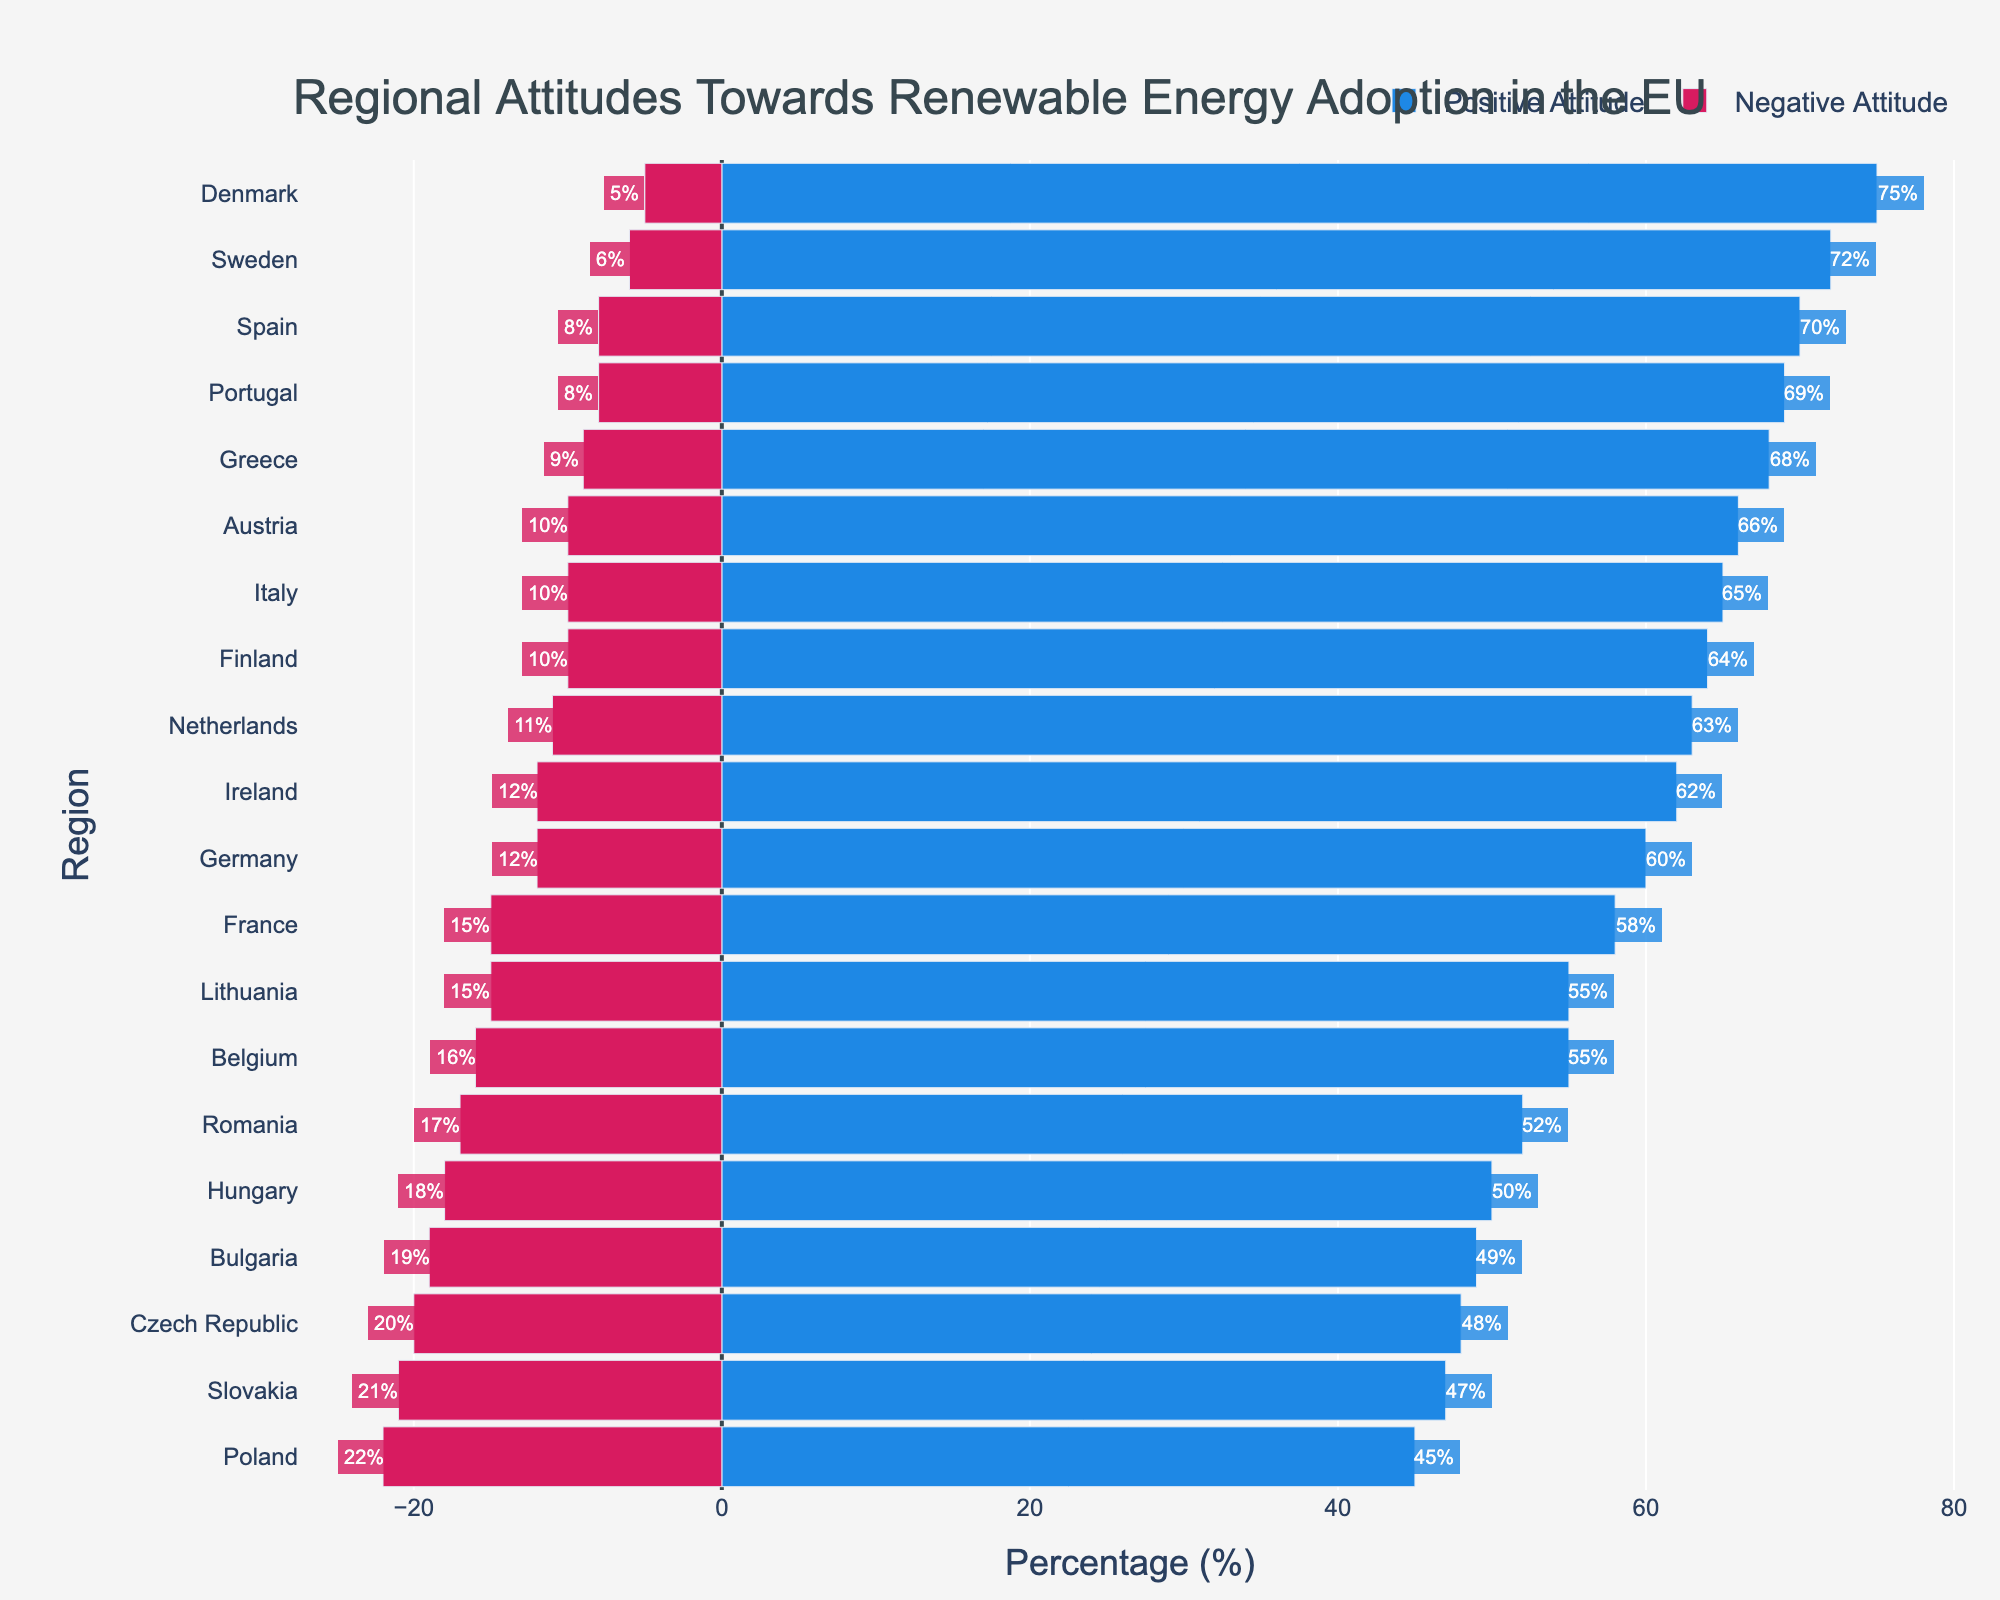Which country shows the highest positive attitude towards renewable energy adoption? The country with the highest blue bar indicates the highest positive attitude. Denmark has the longest blue bar representing 75%.
Answer: Denmark Which country has a larger difference between positive and negative attitudes: Germany or Poland? Calculate the difference for both countries. Germany: 60% - 12% = 48%; Poland: 45% - 22% = 23%. Germany has a larger difference.
Answer: Germany What is the sum of the negative attitudes in Sweden and Finland? Add the negative percentages of both countries: Sweden (6%) + Finland (10%) = 16%.
Answer: 16% Which three countries have the lowest negative attitudes? Look for the shortest red bars representing negative attitudes. Denmark (5%), Sweden (6%), and Spain/Portugal (8%).
Answer: Denmark, Sweden, Spain/Portugal How many countries have a positive attitude of over 60%? Count the countries with blue bars extending beyond the 60% mark. Germany, France, Italy, Spain, Sweden, Netherlands, Greece, Finland, Portugal, Austria, Denmark, Ireland (12 countries).
Answer: 12 Which country has almost equal positive and negative attitudes? Look for the country where the blue and the red bar lengths are nearly the same. Slovakia: Positive (47%), Negative (21%) (Difference 26%); Czech Republic is closer with Positive (48%), Negative (20%) (Difference 28%). Romania also quite close but farther difference.
Answer: Slovakia Compared to Hungary, does Belgium have a higher or lower net positive attitude? Hungary: Positive - Negative = 32%; Belgium: Positive - Negative = 39%. Therefore, Belgium is higher.
Answer: Higher What is the average positive attitude towards renewable energy in Italy, Spain, and Greece? Sum the positive percentages and divide by 3. (65% + 70% + 68%) / 3 = 67.67%.
Answer: 67.67% Among the countries listed, which one has the highest combined percentage of attitudes (positive + negative)? Calculate the sum for each country. Denmark: 75% + 5% = 80% has the highest combined percentage.
Answer: Denmark Do more than half of the listed countries have a negative attitude below 15%? Count the countries with red bars less than 15%. Germany, France, Italy, Spain, Sweden, Netherlands, Greece, Finland, Portugal, Austria, Denmark, Ireland, Lithuania: 13 out of 18.
Answer: Yes 